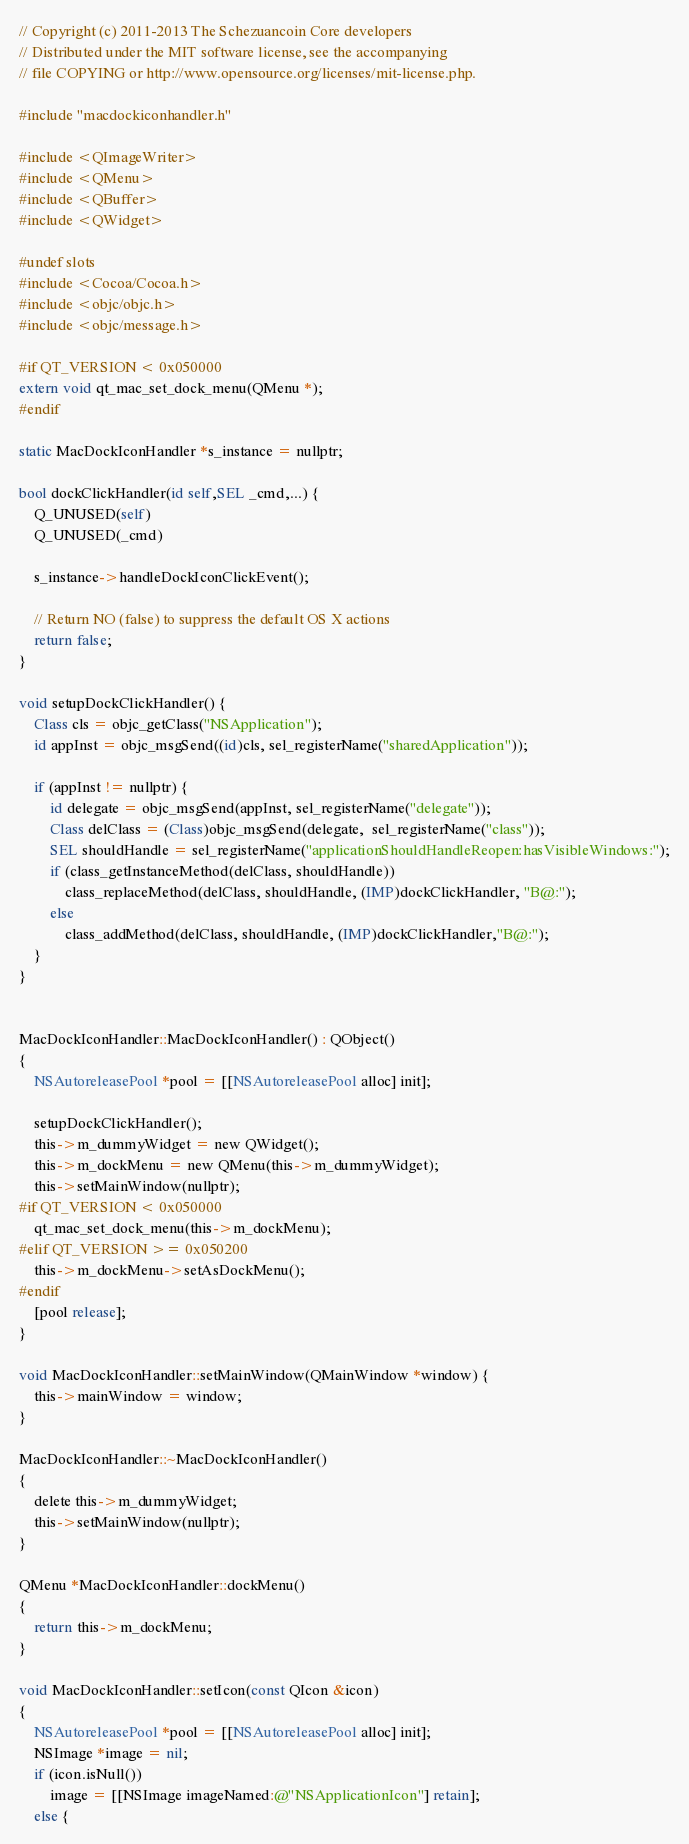<code> <loc_0><loc_0><loc_500><loc_500><_ObjectiveC_>// Copyright (c) 2011-2013 The Schezuancoin Core developers
// Distributed under the MIT software license, see the accompanying
// file COPYING or http://www.opensource.org/licenses/mit-license.php.

#include "macdockiconhandler.h"

#include <QImageWriter>
#include <QMenu>
#include <QBuffer>
#include <QWidget>

#undef slots
#include <Cocoa/Cocoa.h>
#include <objc/objc.h>
#include <objc/message.h>

#if QT_VERSION < 0x050000
extern void qt_mac_set_dock_menu(QMenu *);
#endif

static MacDockIconHandler *s_instance = nullptr;

bool dockClickHandler(id self,SEL _cmd,...) {
    Q_UNUSED(self)
    Q_UNUSED(_cmd)
    
    s_instance->handleDockIconClickEvent();
    
    // Return NO (false) to suppress the default OS X actions
    return false;
}

void setupDockClickHandler() {
    Class cls = objc_getClass("NSApplication");
    id appInst = objc_msgSend((id)cls, sel_registerName("sharedApplication"));
    
    if (appInst != nullptr) {
        id delegate = objc_msgSend(appInst, sel_registerName("delegate"));
        Class delClass = (Class)objc_msgSend(delegate,  sel_registerName("class"));
        SEL shouldHandle = sel_registerName("applicationShouldHandleReopen:hasVisibleWindows:");
        if (class_getInstanceMethod(delClass, shouldHandle))
            class_replaceMethod(delClass, shouldHandle, (IMP)dockClickHandler, "B@:");
        else
            class_addMethod(delClass, shouldHandle, (IMP)dockClickHandler,"B@:");
    }
}


MacDockIconHandler::MacDockIconHandler() : QObject()
{
    NSAutoreleasePool *pool = [[NSAutoreleasePool alloc] init];

    setupDockClickHandler();
    this->m_dummyWidget = new QWidget();
    this->m_dockMenu = new QMenu(this->m_dummyWidget);
    this->setMainWindow(nullptr);
#if QT_VERSION < 0x050000
    qt_mac_set_dock_menu(this->m_dockMenu);
#elif QT_VERSION >= 0x050200
    this->m_dockMenu->setAsDockMenu();
#endif
    [pool release];
}

void MacDockIconHandler::setMainWindow(QMainWindow *window) {
    this->mainWindow = window;
}

MacDockIconHandler::~MacDockIconHandler()
{
    delete this->m_dummyWidget;
    this->setMainWindow(nullptr);
}

QMenu *MacDockIconHandler::dockMenu()
{
    return this->m_dockMenu;
}

void MacDockIconHandler::setIcon(const QIcon &icon)
{
    NSAutoreleasePool *pool = [[NSAutoreleasePool alloc] init];
    NSImage *image = nil;
    if (icon.isNull())
        image = [[NSImage imageNamed:@"NSApplicationIcon"] retain];
    else {</code> 